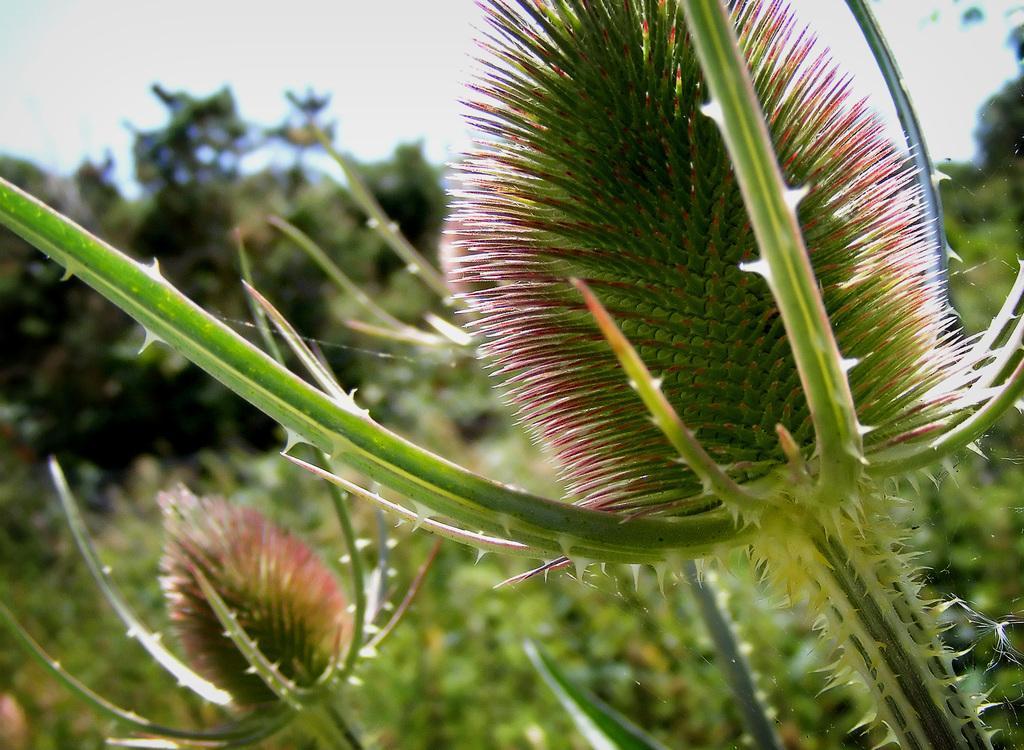Could you give a brief overview of what you see in this image? In this image I see the plants in front and I see the spider web over here and I can also see few more spider webs and I see that it is blurred in the background. 